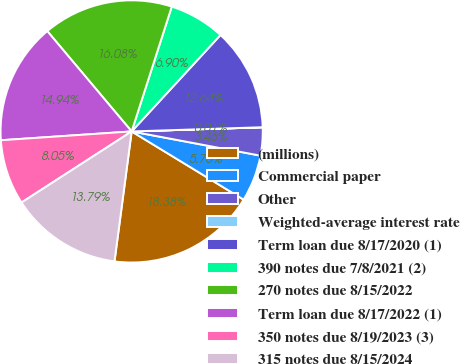Convert chart. <chart><loc_0><loc_0><loc_500><loc_500><pie_chart><fcel>(millions)<fcel>Commercial paper<fcel>Other<fcel>Weighted-average interest rate<fcel>Term loan due 8/17/2020 (1)<fcel>390 notes due 7/8/2021 (2)<fcel>270 notes due 8/15/2022<fcel>Term loan due 8/17/2022 (1)<fcel>350 notes due 8/19/2023 (3)<fcel>315 notes due 8/15/2024<nl><fcel>18.38%<fcel>5.75%<fcel>3.46%<fcel>0.01%<fcel>12.64%<fcel>6.9%<fcel>16.08%<fcel>14.94%<fcel>8.05%<fcel>13.79%<nl></chart> 